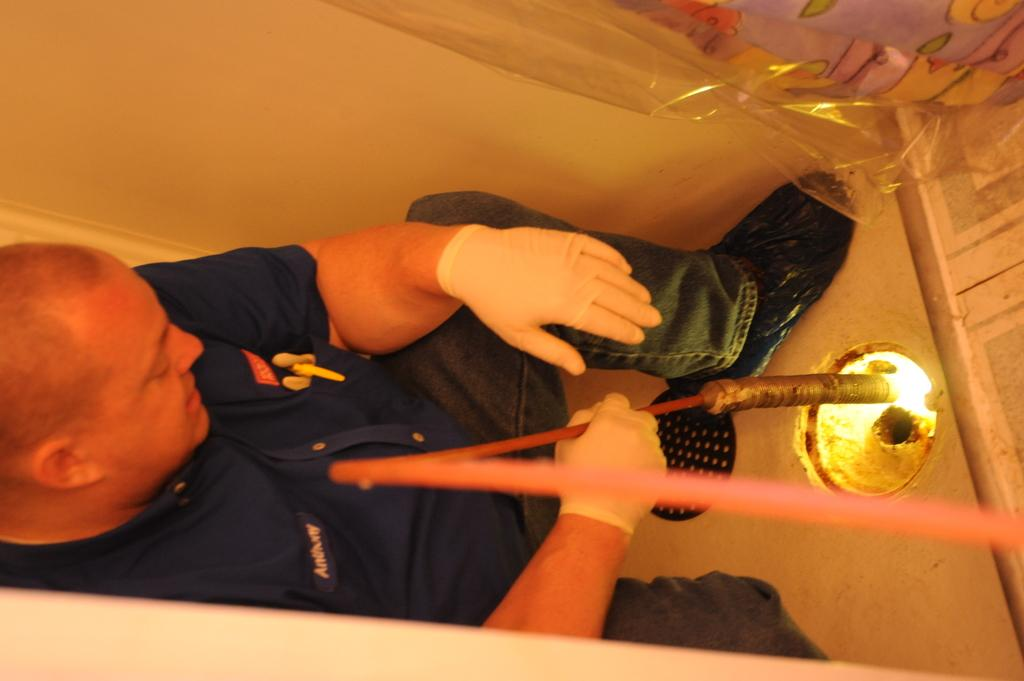What is the man doing in the image? The man is sitting on a chair in the image. What object is the man holding? The man is holding a stick in the image. Can you describe the source of the flame in the image? There is a flame visible in the image, but the source is not specified. What are the two main surfaces in the image? There is a wall and a floor in the image. What type of riddle is the man trying to solve with his chin in the image? There is no riddle or chin-related activity present in the image; the man is simply sitting on a chair and holding a stick. 